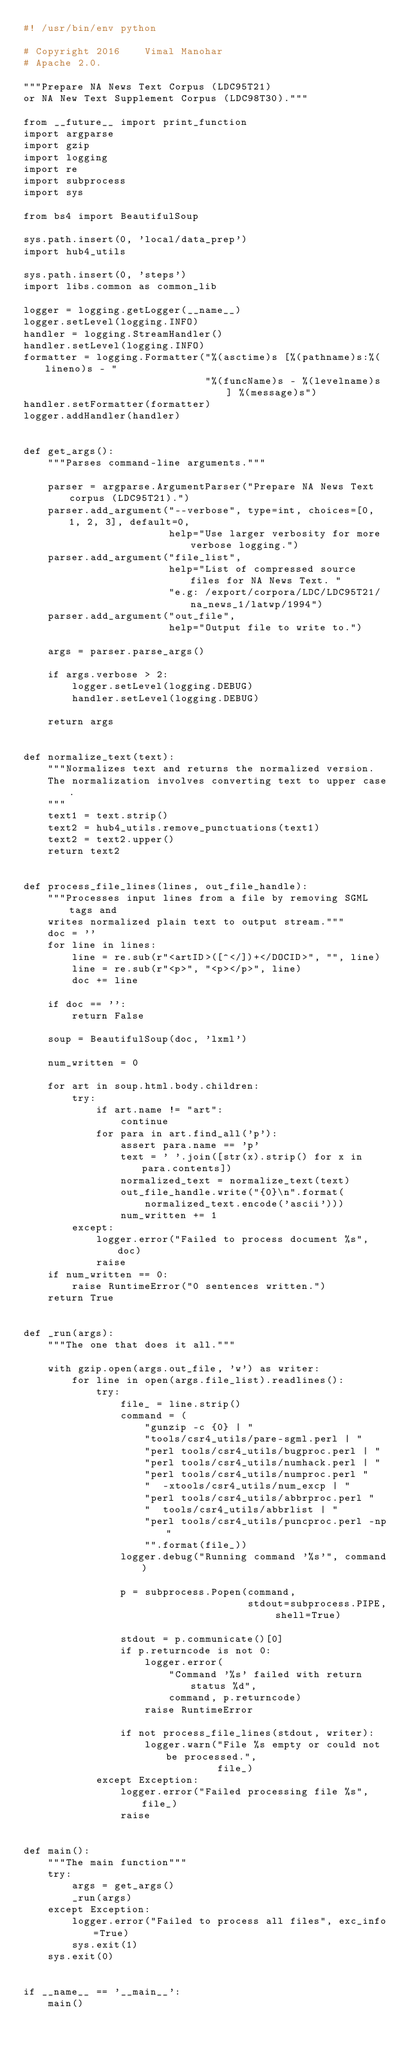<code> <loc_0><loc_0><loc_500><loc_500><_Python_>#! /usr/bin/env python

# Copyright 2016    Vimal Manohar
# Apache 2.0.

"""Prepare NA News Text Corpus (LDC95T21)
or NA New Text Supplement Corpus (LDC98T30)."""

from __future__ import print_function
import argparse
import gzip
import logging
import re
import subprocess
import sys

from bs4 import BeautifulSoup

sys.path.insert(0, 'local/data_prep')
import hub4_utils

sys.path.insert(0, 'steps')
import libs.common as common_lib

logger = logging.getLogger(__name__)
logger.setLevel(logging.INFO)
handler = logging.StreamHandler()
handler.setLevel(logging.INFO)
formatter = logging.Formatter("%(asctime)s [%(pathname)s:%(lineno)s - "
                              "%(funcName)s - %(levelname)s ] %(message)s")
handler.setFormatter(formatter)
logger.addHandler(handler)


def get_args():
    """Parses command-line arguments."""

    parser = argparse.ArgumentParser("Prepare NA News Text corpus (LDC95T21).")
    parser.add_argument("--verbose", type=int, choices=[0, 1, 2, 3], default=0,
                        help="Use larger verbosity for more verbose logging.")
    parser.add_argument("file_list",
                        help="List of compressed source files for NA News Text. "
                        "e.g: /export/corpora/LDC/LDC95T21/na_news_1/latwp/1994")
    parser.add_argument("out_file",
                        help="Output file to write to.")

    args = parser.parse_args()

    if args.verbose > 2:
        logger.setLevel(logging.DEBUG)
        handler.setLevel(logging.DEBUG)

    return args


def normalize_text(text):
    """Normalizes text and returns the normalized version.
    The normalization involves converting text to upper case.
    """
    text1 = text.strip()
    text2 = hub4_utils.remove_punctuations(text1)
    text2 = text2.upper()
    return text2


def process_file_lines(lines, out_file_handle):
    """Processes input lines from a file by removing SGML tags and
    writes normalized plain text to output stream."""
    doc = ''
    for line in lines:
        line = re.sub(r"<artID>([^</])+</DOCID>", "", line)
        line = re.sub(r"<p>", "<p></p>", line)
        doc += line

    if doc == '':
        return False

    soup = BeautifulSoup(doc, 'lxml')

    num_written = 0

    for art in soup.html.body.children:
        try:
            if art.name != "art":
                continue
            for para in art.find_all('p'):
                assert para.name == 'p'
                text = ' '.join([str(x).strip() for x in para.contents])
                normalized_text = normalize_text(text)
                out_file_handle.write("{0}\n".format(
                    normalized_text.encode('ascii')))
                num_written += 1
        except:
            logger.error("Failed to process document %s", doc)
            raise
    if num_written == 0:
        raise RuntimeError("0 sentences written.")
    return True


def _run(args):
    """The one that does it all."""

    with gzip.open(args.out_file, 'w') as writer:
        for line in open(args.file_list).readlines():
            try:
                file_ = line.strip()
                command = (
                    "gunzip -c {0} | "
                    "tools/csr4_utils/pare-sgml.perl | "
                    "perl tools/csr4_utils/bugproc.perl | "
                    "perl tools/csr4_utils/numhack.perl | "
                    "perl tools/csr4_utils/numproc.perl "
                    "  -xtools/csr4_utils/num_excp | "
                    "perl tools/csr4_utils/abbrproc.perl "
                    "  tools/csr4_utils/abbrlist | "
                    "perl tools/csr4_utils/puncproc.perl -np"
                    "".format(file_))
                logger.debug("Running command '%s'", command)

                p = subprocess.Popen(command,
                                     stdout=subprocess.PIPE, shell=True)

                stdout = p.communicate()[0]
                if p.returncode is not 0:
                    logger.error(
                        "Command '%s' failed with return status %d",
                        command, p.returncode)
                    raise RuntimeError

                if not process_file_lines(stdout, writer):
                    logger.warn("File %s empty or could not be processed.",
                                file_)
            except Exception:
                logger.error("Failed processing file %s", file_)
                raise


def main():
    """The main function"""
    try:
        args = get_args()
        _run(args)
    except Exception:
        logger.error("Failed to process all files", exc_info=True)
        sys.exit(1)
    sys.exit(0)


if __name__ == '__main__':
    main()
</code> 